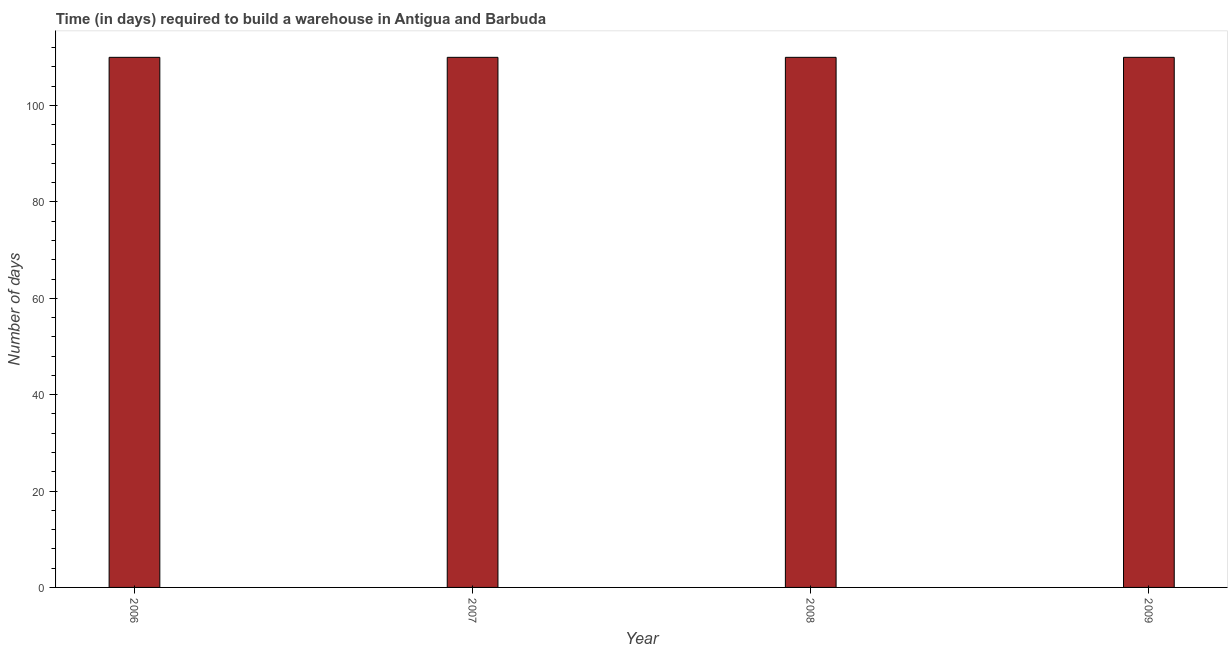Does the graph contain any zero values?
Your response must be concise. No. Does the graph contain grids?
Your answer should be compact. No. What is the title of the graph?
Provide a short and direct response. Time (in days) required to build a warehouse in Antigua and Barbuda. What is the label or title of the Y-axis?
Offer a terse response. Number of days. What is the time required to build a warehouse in 2008?
Your answer should be very brief. 110. Across all years, what is the maximum time required to build a warehouse?
Offer a terse response. 110. Across all years, what is the minimum time required to build a warehouse?
Your answer should be compact. 110. In which year was the time required to build a warehouse minimum?
Offer a terse response. 2006. What is the sum of the time required to build a warehouse?
Provide a short and direct response. 440. What is the average time required to build a warehouse per year?
Offer a terse response. 110. What is the median time required to build a warehouse?
Keep it short and to the point. 110. Is the time required to build a warehouse in 2006 less than that in 2009?
Your response must be concise. No. Is the sum of the time required to build a warehouse in 2006 and 2009 greater than the maximum time required to build a warehouse across all years?
Keep it short and to the point. Yes. How many bars are there?
Keep it short and to the point. 4. Are all the bars in the graph horizontal?
Offer a terse response. No. How many years are there in the graph?
Ensure brevity in your answer.  4. What is the Number of days of 2006?
Provide a short and direct response. 110. What is the Number of days in 2007?
Your answer should be very brief. 110. What is the Number of days in 2008?
Ensure brevity in your answer.  110. What is the Number of days in 2009?
Make the answer very short. 110. What is the difference between the Number of days in 2006 and 2007?
Keep it short and to the point. 0. What is the difference between the Number of days in 2006 and 2008?
Your answer should be compact. 0. What is the difference between the Number of days in 2006 and 2009?
Your response must be concise. 0. What is the difference between the Number of days in 2007 and 2009?
Keep it short and to the point. 0. What is the difference between the Number of days in 2008 and 2009?
Your answer should be very brief. 0. What is the ratio of the Number of days in 2006 to that in 2007?
Provide a succinct answer. 1. What is the ratio of the Number of days in 2006 to that in 2009?
Provide a short and direct response. 1. What is the ratio of the Number of days in 2007 to that in 2008?
Give a very brief answer. 1. 